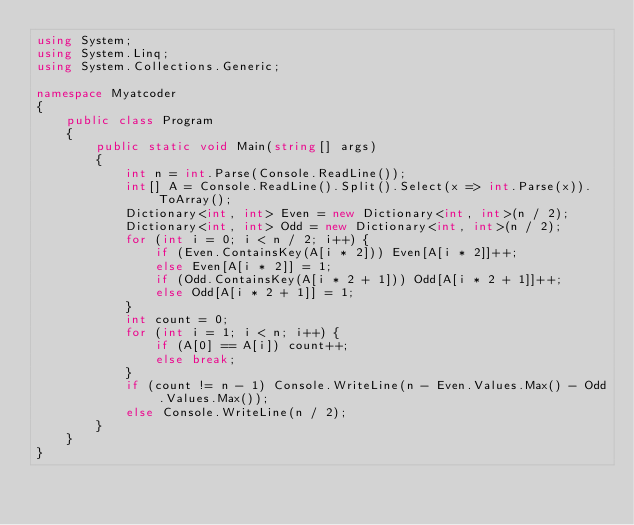<code> <loc_0><loc_0><loc_500><loc_500><_C#_>using System;
using System.Linq;
using System.Collections.Generic;

namespace Myatcoder
{
    public class Program
    {
        public static void Main(string[] args)
        {
            int n = int.Parse(Console.ReadLine());
            int[] A = Console.ReadLine().Split().Select(x => int.Parse(x)).ToArray();
            Dictionary<int, int> Even = new Dictionary<int, int>(n / 2);
            Dictionary<int, int> Odd = new Dictionary<int, int>(n / 2);
            for (int i = 0; i < n / 2; i++) {
                if (Even.ContainsKey(A[i * 2])) Even[A[i * 2]]++;
                else Even[A[i * 2]] = 1;
                if (Odd.ContainsKey(A[i * 2 + 1])) Odd[A[i * 2 + 1]]++;
                else Odd[A[i * 2 + 1]] = 1;
            }
            int count = 0;
            for (int i = 1; i < n; i++) {
                if (A[0] == A[i]) count++;
                else break;
            }
            if (count != n - 1) Console.WriteLine(n - Even.Values.Max() - Odd.Values.Max());
            else Console.WriteLine(n / 2);
        }
    }
}</code> 